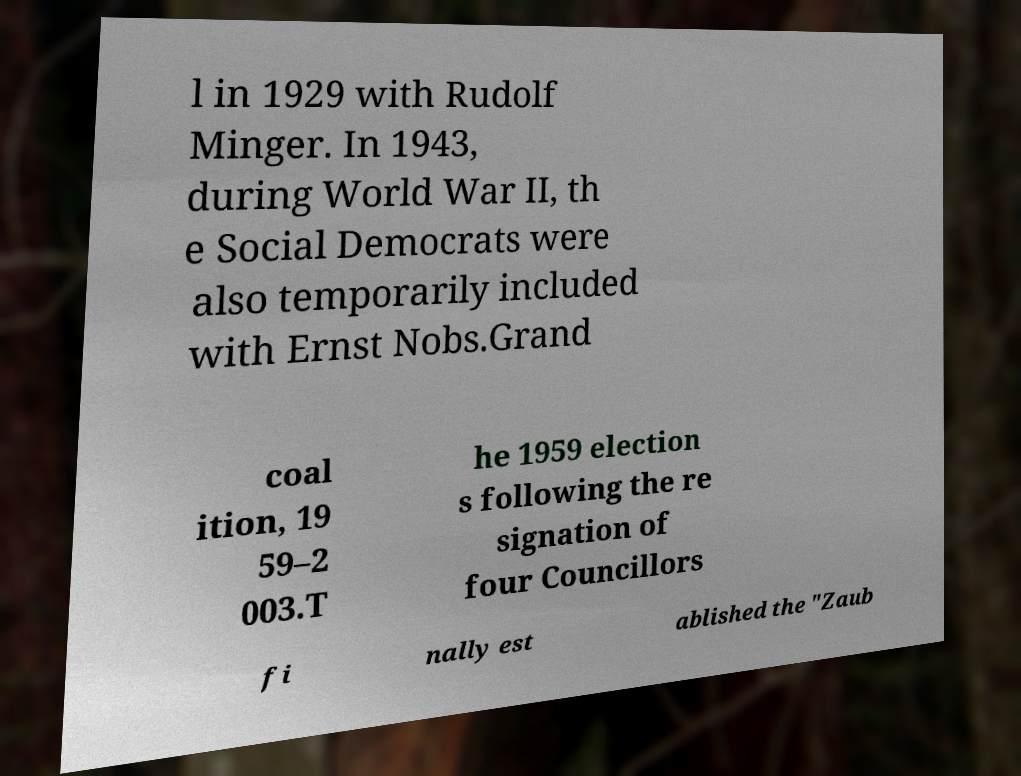Can you read and provide the text displayed in the image?This photo seems to have some interesting text. Can you extract and type it out for me? l in 1929 with Rudolf Minger. In 1943, during World War II, th e Social Democrats were also temporarily included with Ernst Nobs.Grand coal ition, 19 59–2 003.T he 1959 election s following the re signation of four Councillors fi nally est ablished the "Zaub 